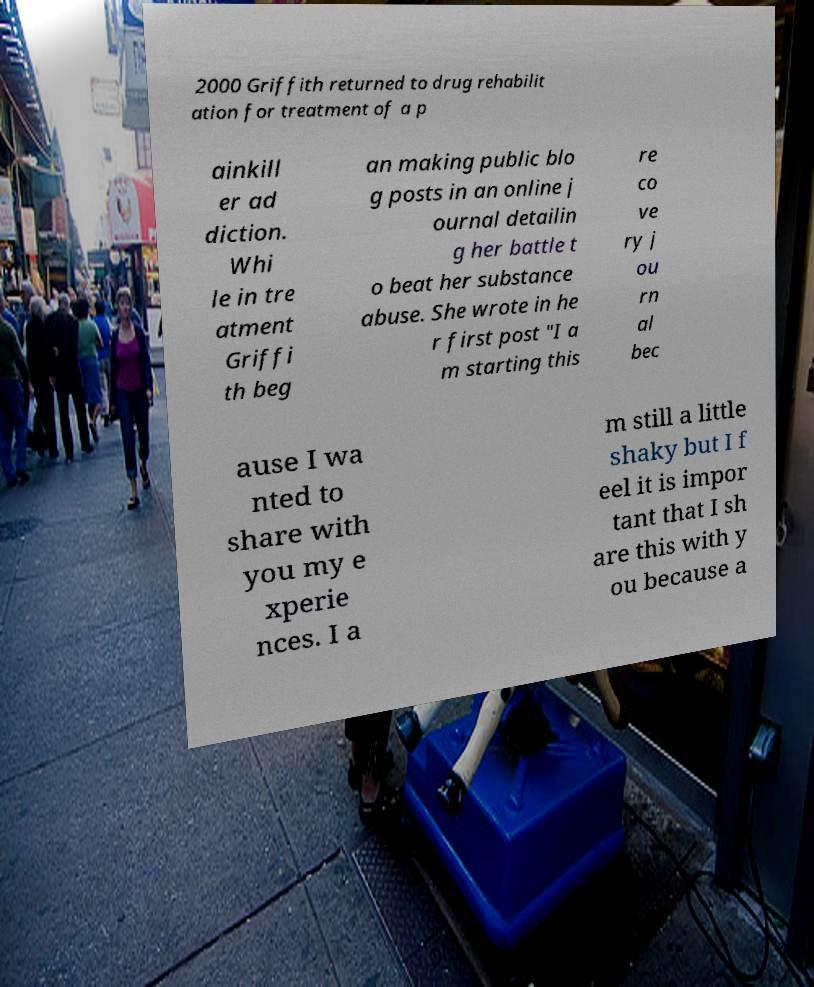I need the written content from this picture converted into text. Can you do that? 2000 Griffith returned to drug rehabilit ation for treatment of a p ainkill er ad diction. Whi le in tre atment Griffi th beg an making public blo g posts in an online j ournal detailin g her battle t o beat her substance abuse. She wrote in he r first post "I a m starting this re co ve ry j ou rn al bec ause I wa nted to share with you my e xperie nces. I a m still a little shaky but I f eel it is impor tant that I sh are this with y ou because a 